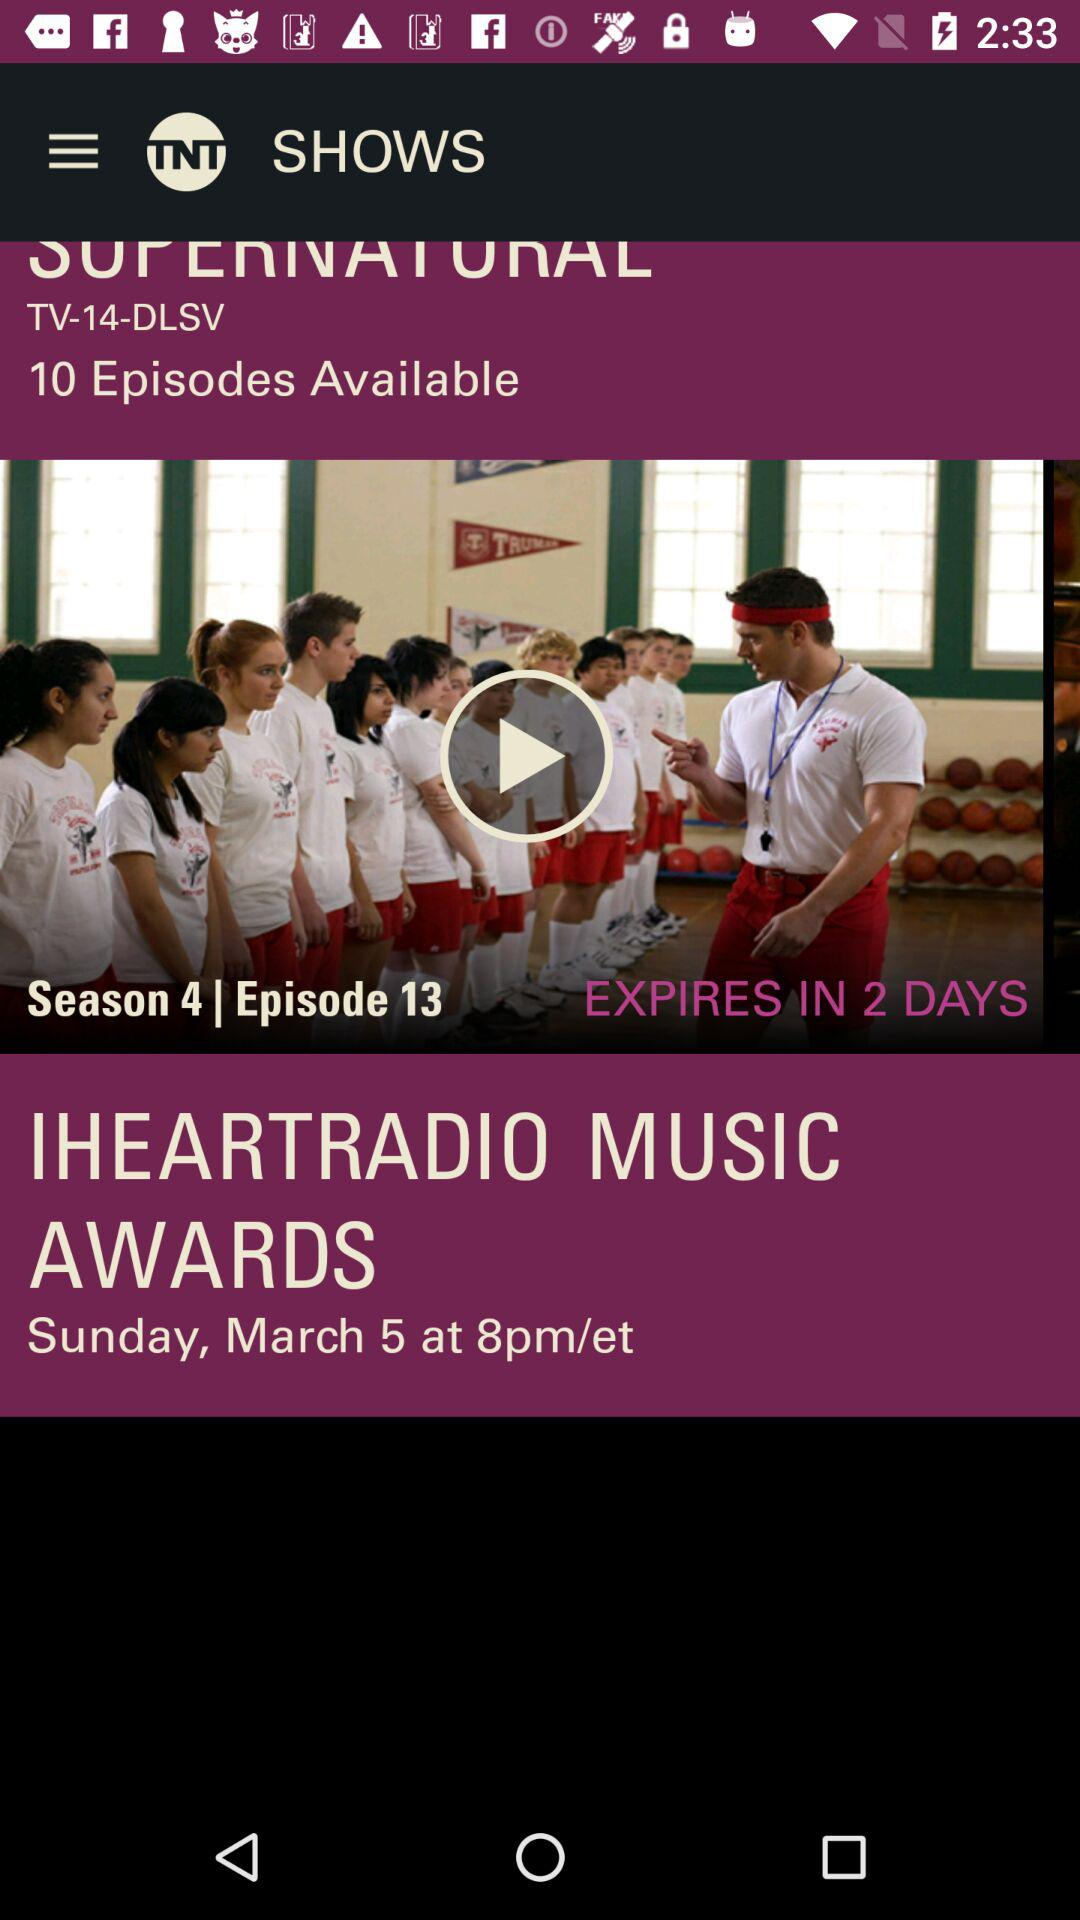How many days before the IHEARTRAIO MUSIC AWARDS will the episode expire?
Answer the question using a single word or phrase. 2 